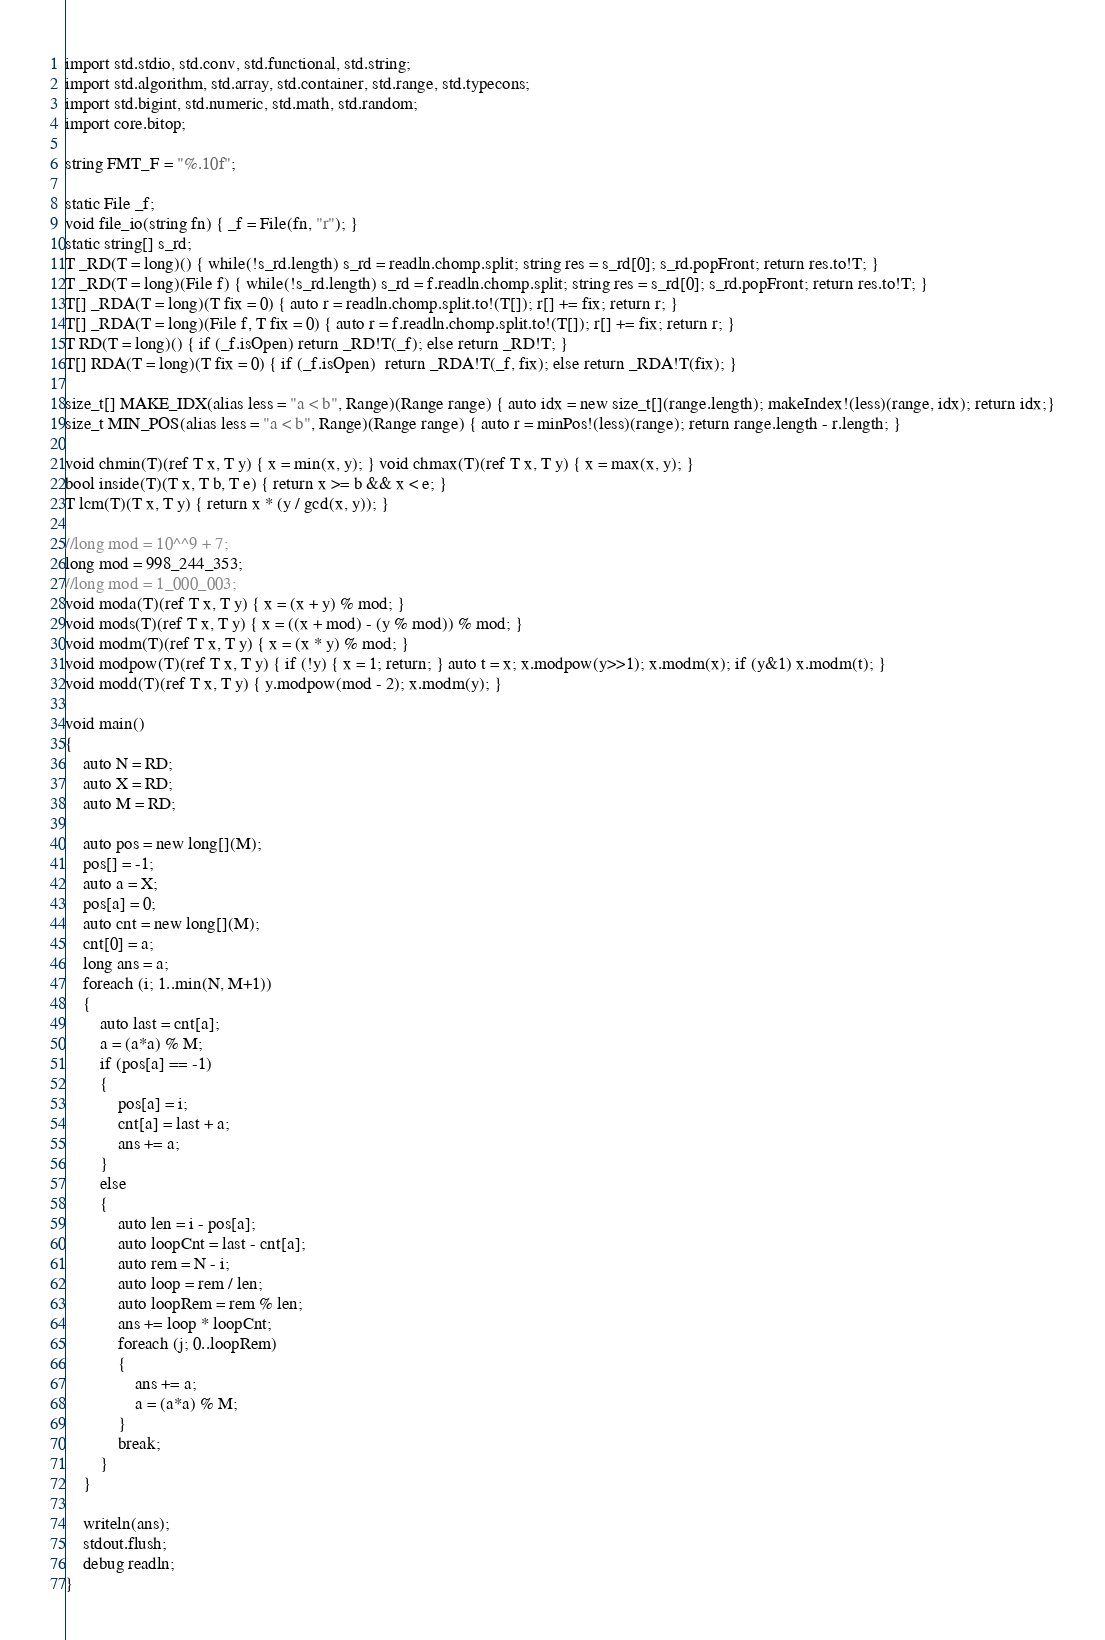Convert code to text. <code><loc_0><loc_0><loc_500><loc_500><_D_>import std.stdio, std.conv, std.functional, std.string;
import std.algorithm, std.array, std.container, std.range, std.typecons;
import std.bigint, std.numeric, std.math, std.random;
import core.bitop;

string FMT_F = "%.10f";

static File _f;
void file_io(string fn) { _f = File(fn, "r"); }
static string[] s_rd;
T _RD(T = long)() { while(!s_rd.length) s_rd = readln.chomp.split; string res = s_rd[0]; s_rd.popFront; return res.to!T; }
T _RD(T = long)(File f) { while(!s_rd.length) s_rd = f.readln.chomp.split; string res = s_rd[0]; s_rd.popFront; return res.to!T; }
T[] _RDA(T = long)(T fix = 0) { auto r = readln.chomp.split.to!(T[]); r[] += fix; return r; }
T[] _RDA(T = long)(File f, T fix = 0) { auto r = f.readln.chomp.split.to!(T[]); r[] += fix; return r; }
T RD(T = long)() { if (_f.isOpen) return _RD!T(_f); else return _RD!T; }
T[] RDA(T = long)(T fix = 0) { if (_f.isOpen)  return _RDA!T(_f, fix); else return _RDA!T(fix); }

size_t[] MAKE_IDX(alias less = "a < b", Range)(Range range) { auto idx = new size_t[](range.length); makeIndex!(less)(range, idx); return idx;}
size_t MIN_POS(alias less = "a < b", Range)(Range range) { auto r = minPos!(less)(range); return range.length - r.length; }

void chmin(T)(ref T x, T y) { x = min(x, y); } void chmax(T)(ref T x, T y) { x = max(x, y); }
bool inside(T)(T x, T b, T e) { return x >= b && x < e; }
T lcm(T)(T x, T y) { return x * (y / gcd(x, y)); }

//long mod = 10^^9 + 7;
long mod = 998_244_353;
//long mod = 1_000_003;
void moda(T)(ref T x, T y) { x = (x + y) % mod; }
void mods(T)(ref T x, T y) { x = ((x + mod) - (y % mod)) % mod; }
void modm(T)(ref T x, T y) { x = (x * y) % mod; }
void modpow(T)(ref T x, T y) { if (!y) { x = 1; return; } auto t = x; x.modpow(y>>1); x.modm(x); if (y&1) x.modm(t); }
void modd(T)(ref T x, T y) { y.modpow(mod - 2); x.modm(y); }

void main()
{
	auto N = RD;
	auto X = RD;
	auto M = RD;
	
	auto pos = new long[](M);
	pos[] = -1;
	auto a = X;
	pos[a] = 0;
	auto cnt = new long[](M);
	cnt[0] = a;
	long ans = a;
	foreach (i; 1..min(N, M+1))
	{
		auto last = cnt[a];
		a = (a*a) % M;
		if (pos[a] == -1)
		{
			pos[a] = i;
			cnt[a] = last + a;
			ans += a;
		}
		else
		{
			auto len = i - pos[a];
			auto loopCnt = last - cnt[a];
			auto rem = N - i;
			auto loop = rem / len;
			auto loopRem = rem % len;
			ans += loop * loopCnt;
			foreach (j; 0..loopRem)
			{
				ans += a;
				a = (a*a) % M;
			}
			break;
		}
	}

	writeln(ans);
	stdout.flush;
	debug readln;
}
</code> 